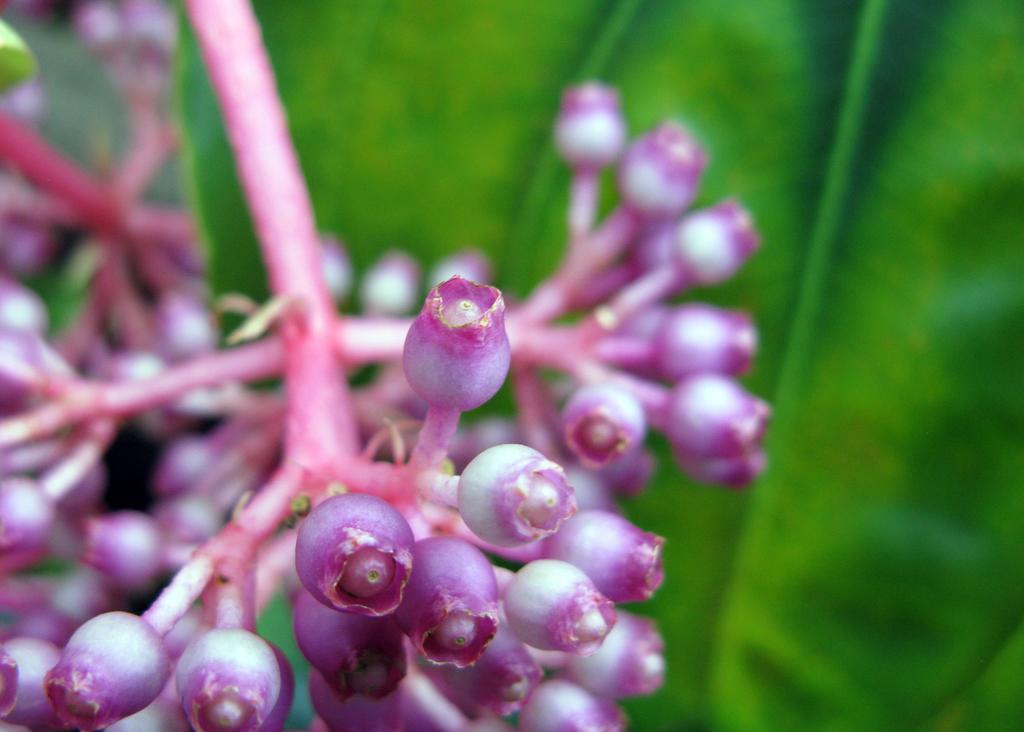What stage of growth are the trees in the image at? The trees in the image have buds and leaves, indicating that they are in a stage of growth. What type of cherry is hanging from the branches of the trees in the image? There are no cherries visible in the image; only buds and leaves are present on the trees. 